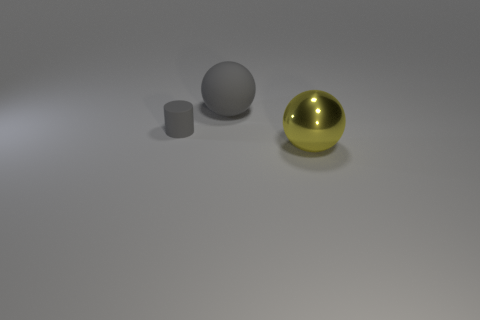Add 3 big yellow balls. How many objects exist? 6 Subtract all spheres. How many objects are left? 1 Add 1 big yellow shiny objects. How many big yellow shiny objects exist? 2 Subtract 0 green cylinders. How many objects are left? 3 Subtract all large matte balls. Subtract all rubber things. How many objects are left? 0 Add 1 gray cylinders. How many gray cylinders are left? 2 